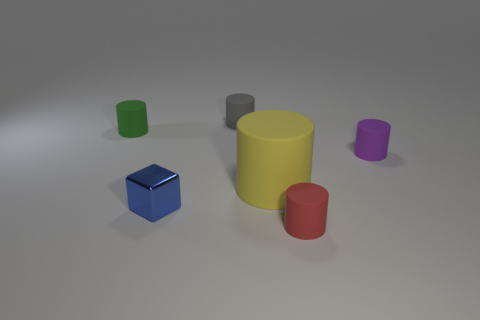Subtract all red rubber cylinders. How many cylinders are left? 4 Subtract all yellow cylinders. How many cylinders are left? 4 Add 3 tiny red cylinders. How many objects exist? 9 Subtract all yellow cylinders. Subtract all blue balls. How many cylinders are left? 4 Subtract all cylinders. How many objects are left? 1 Subtract all tiny blue blocks. Subtract all blue blocks. How many objects are left? 4 Add 3 tiny gray things. How many tiny gray things are left? 4 Add 1 tiny shiny blocks. How many tiny shiny blocks exist? 2 Subtract 0 cyan balls. How many objects are left? 6 